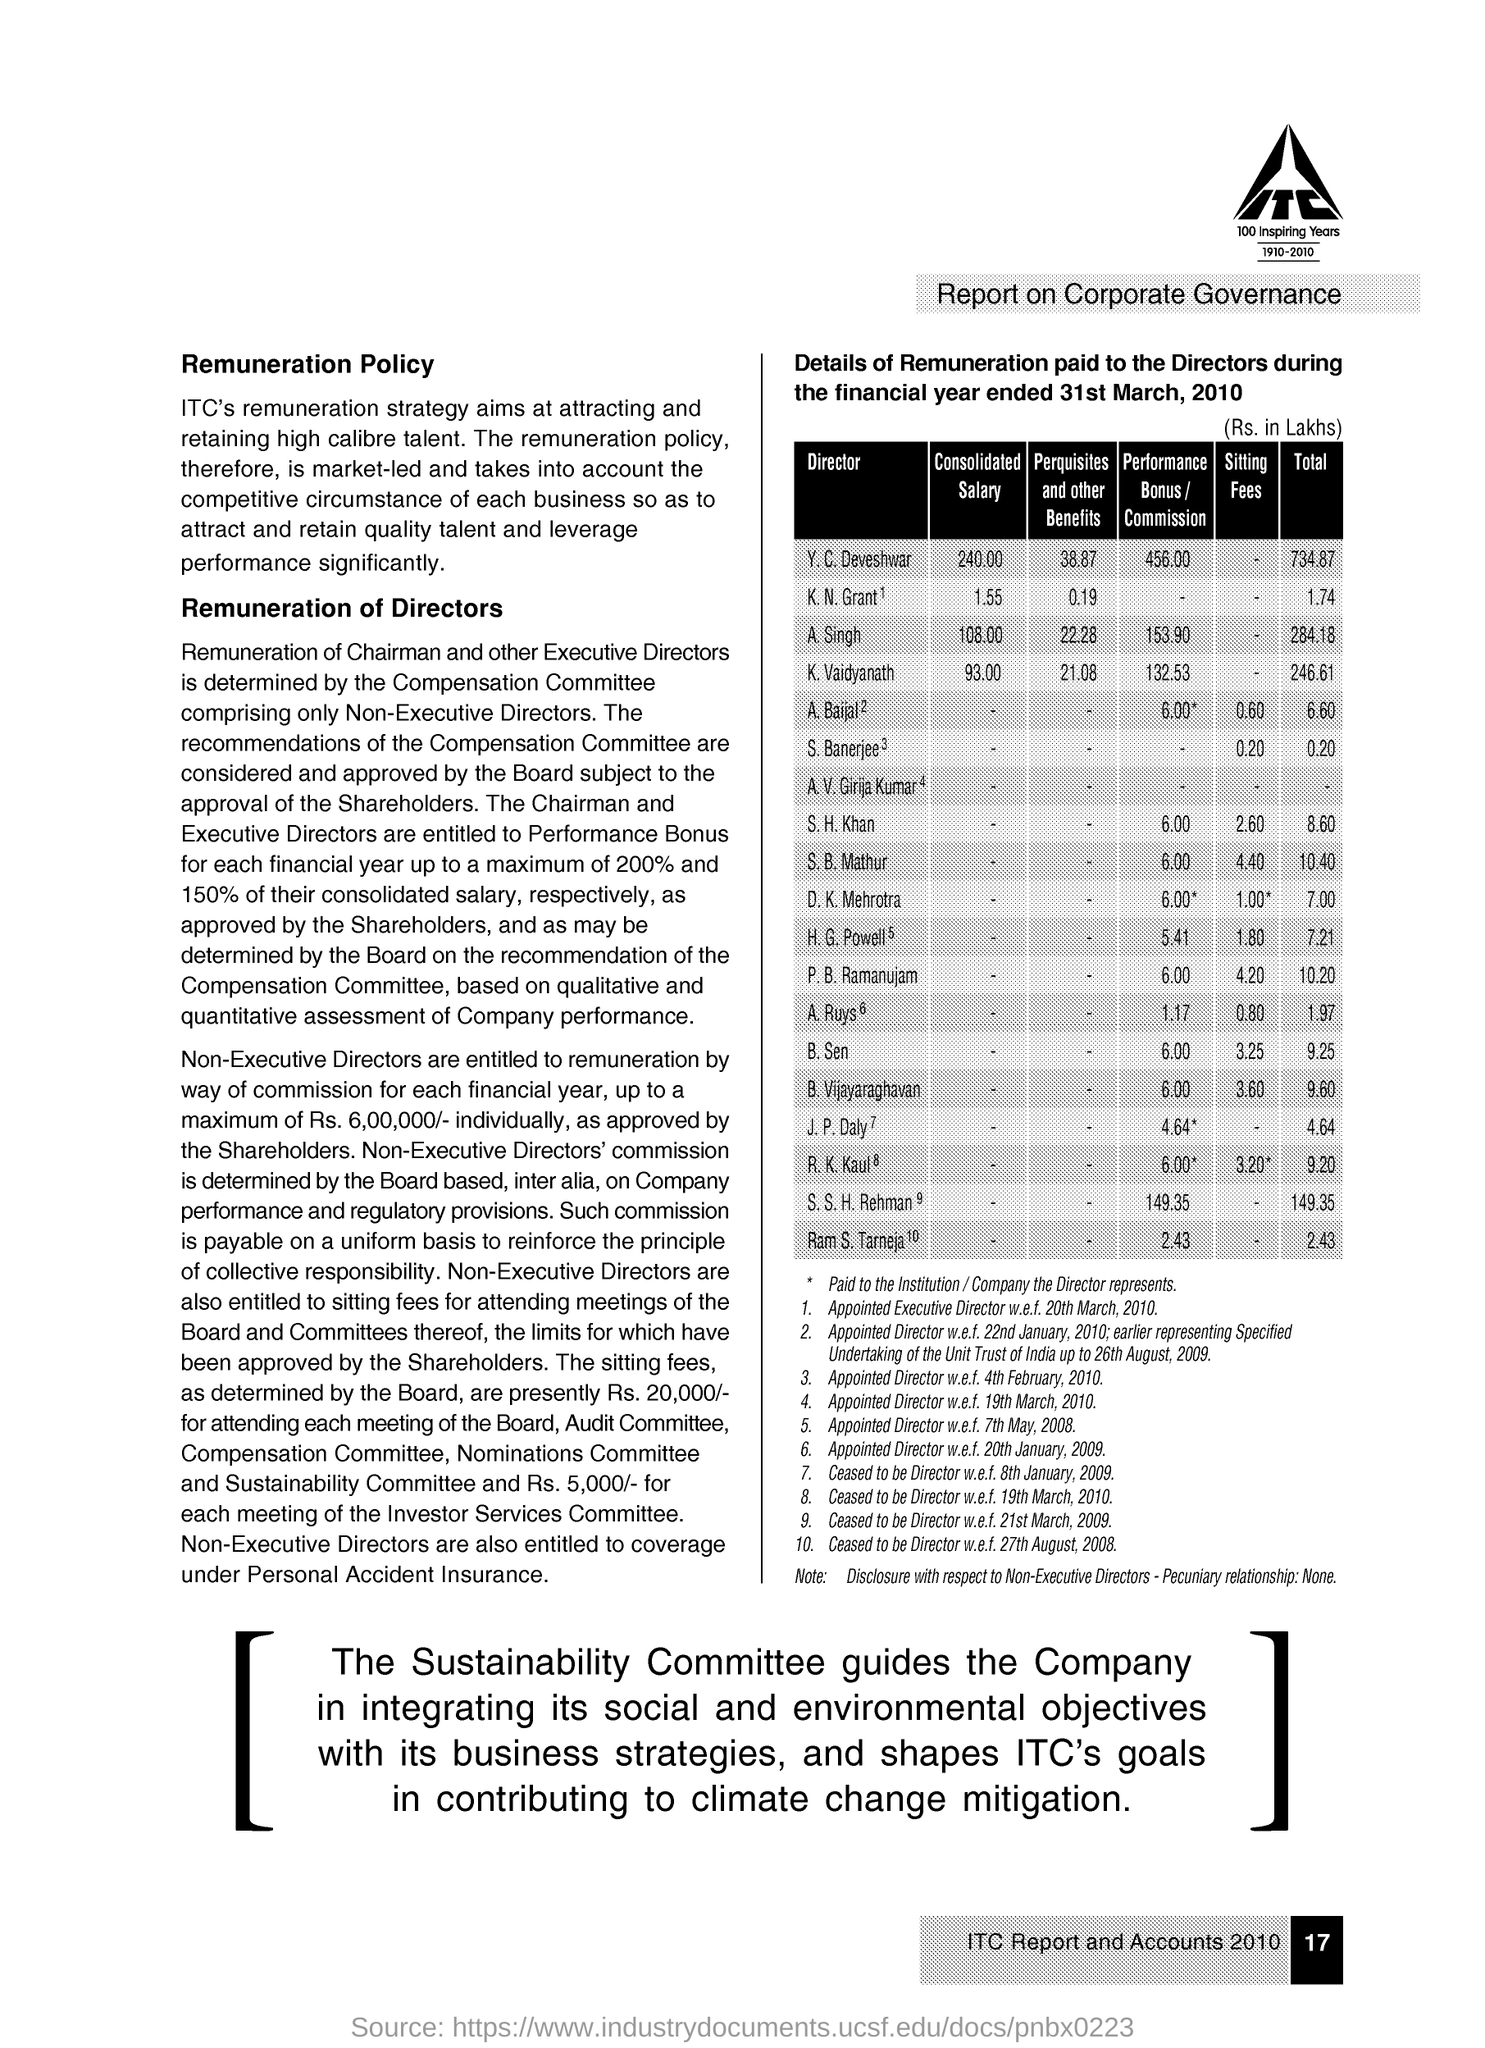What is total money received by K,N Grant in lakhs?
Provide a succinct answer. 1.74. What is the performance bonus of S.H Khan?
Give a very brief answer. 6.00. What is the perquisites and other benefits of K.N Grant?
Provide a short and direct response. 0.19. What is the consolidated salary of A Singh?
Your response must be concise. 108.00. 